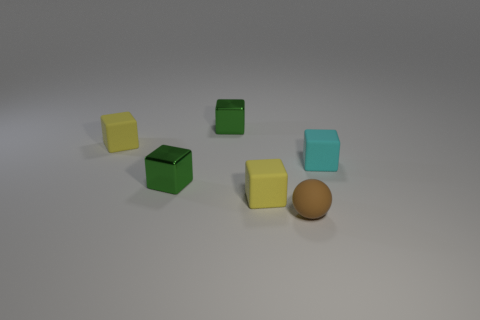Subtract all yellow blocks. How many blocks are left? 3 Subtract all cyan cubes. How many cubes are left? 4 Subtract all red blocks. Subtract all cyan spheres. How many blocks are left? 5 Add 3 tiny green blocks. How many objects exist? 9 Add 6 brown things. How many brown things are left? 7 Add 6 small brown matte things. How many small brown matte things exist? 7 Subtract 0 gray cylinders. How many objects are left? 6 Subtract all cubes. How many objects are left? 1 Subtract all small brown matte objects. Subtract all tiny matte things. How many objects are left? 1 